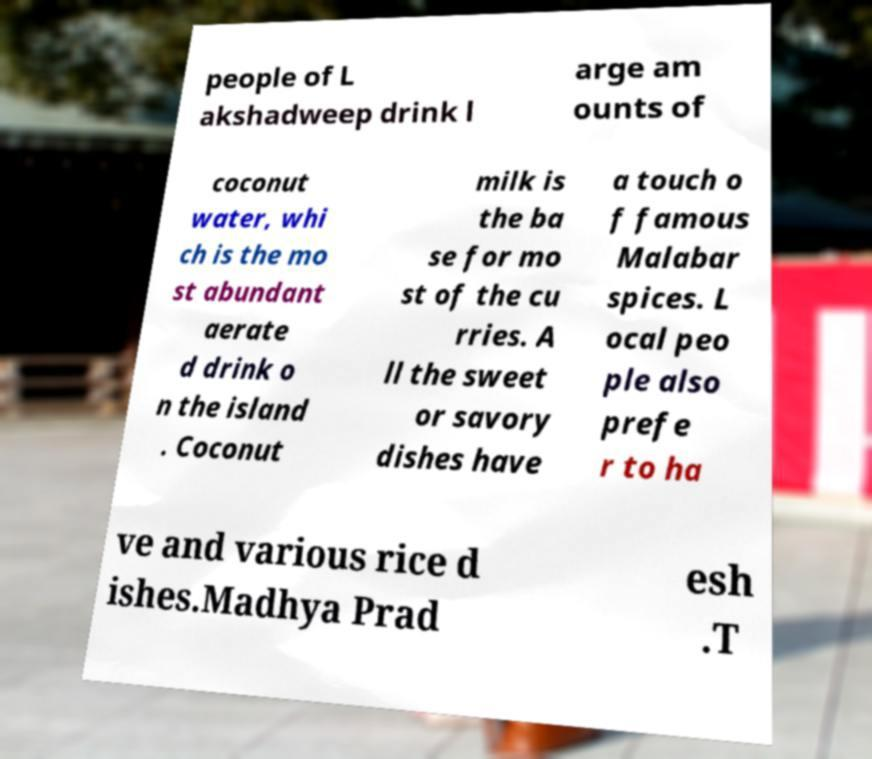Can you read and provide the text displayed in the image?This photo seems to have some interesting text. Can you extract and type it out for me? people of L akshadweep drink l arge am ounts of coconut water, whi ch is the mo st abundant aerate d drink o n the island . Coconut milk is the ba se for mo st of the cu rries. A ll the sweet or savory dishes have a touch o f famous Malabar spices. L ocal peo ple also prefe r to ha ve and various rice d ishes.Madhya Prad esh .T 